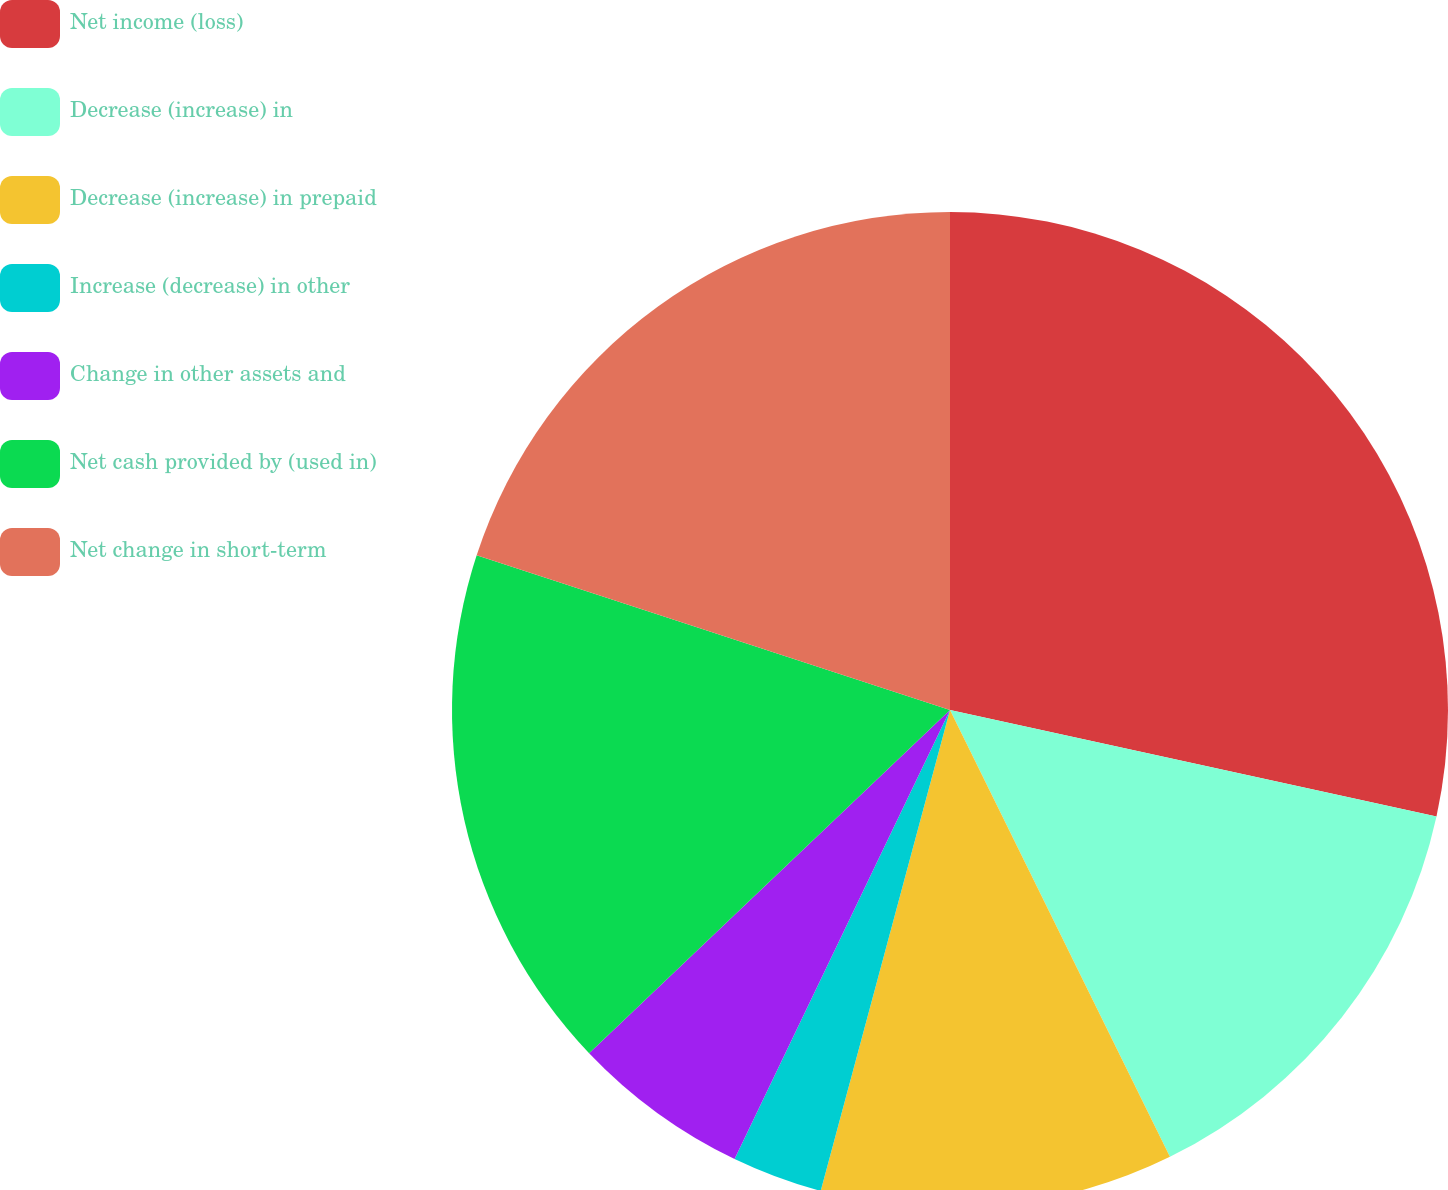Convert chart. <chart><loc_0><loc_0><loc_500><loc_500><pie_chart><fcel>Net income (loss)<fcel>Decrease (increase) in<fcel>Decrease (increase) in prepaid<fcel>Increase (decrease) in other<fcel>Change in other assets and<fcel>Net cash provided by (used in)<fcel>Net change in short-term<nl><fcel>28.43%<fcel>14.29%<fcel>11.46%<fcel>2.94%<fcel>5.78%<fcel>17.13%<fcel>19.97%<nl></chart> 